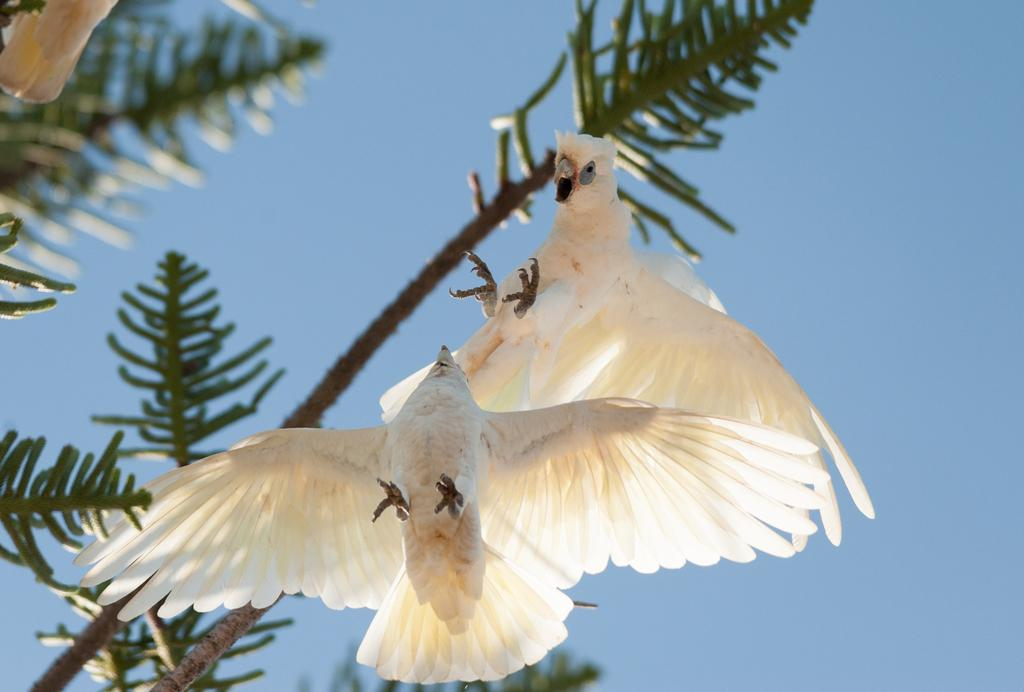How many birds can be seen in the image? There are two birds in the image. What color are the birds? The birds are white in color. What are the birds doing in the image? The birds are flying in the air. What can be seen in the background of the image? There is a tree and the sky visible in the background of the image. What type of spy equipment can be seen in the image? There is no spy equipment present in the image; it features two white birds flying in the air. How is the distribution of the birds in the image? The birds are flying in the air, and their distribution cannot be determined from the image alone. 